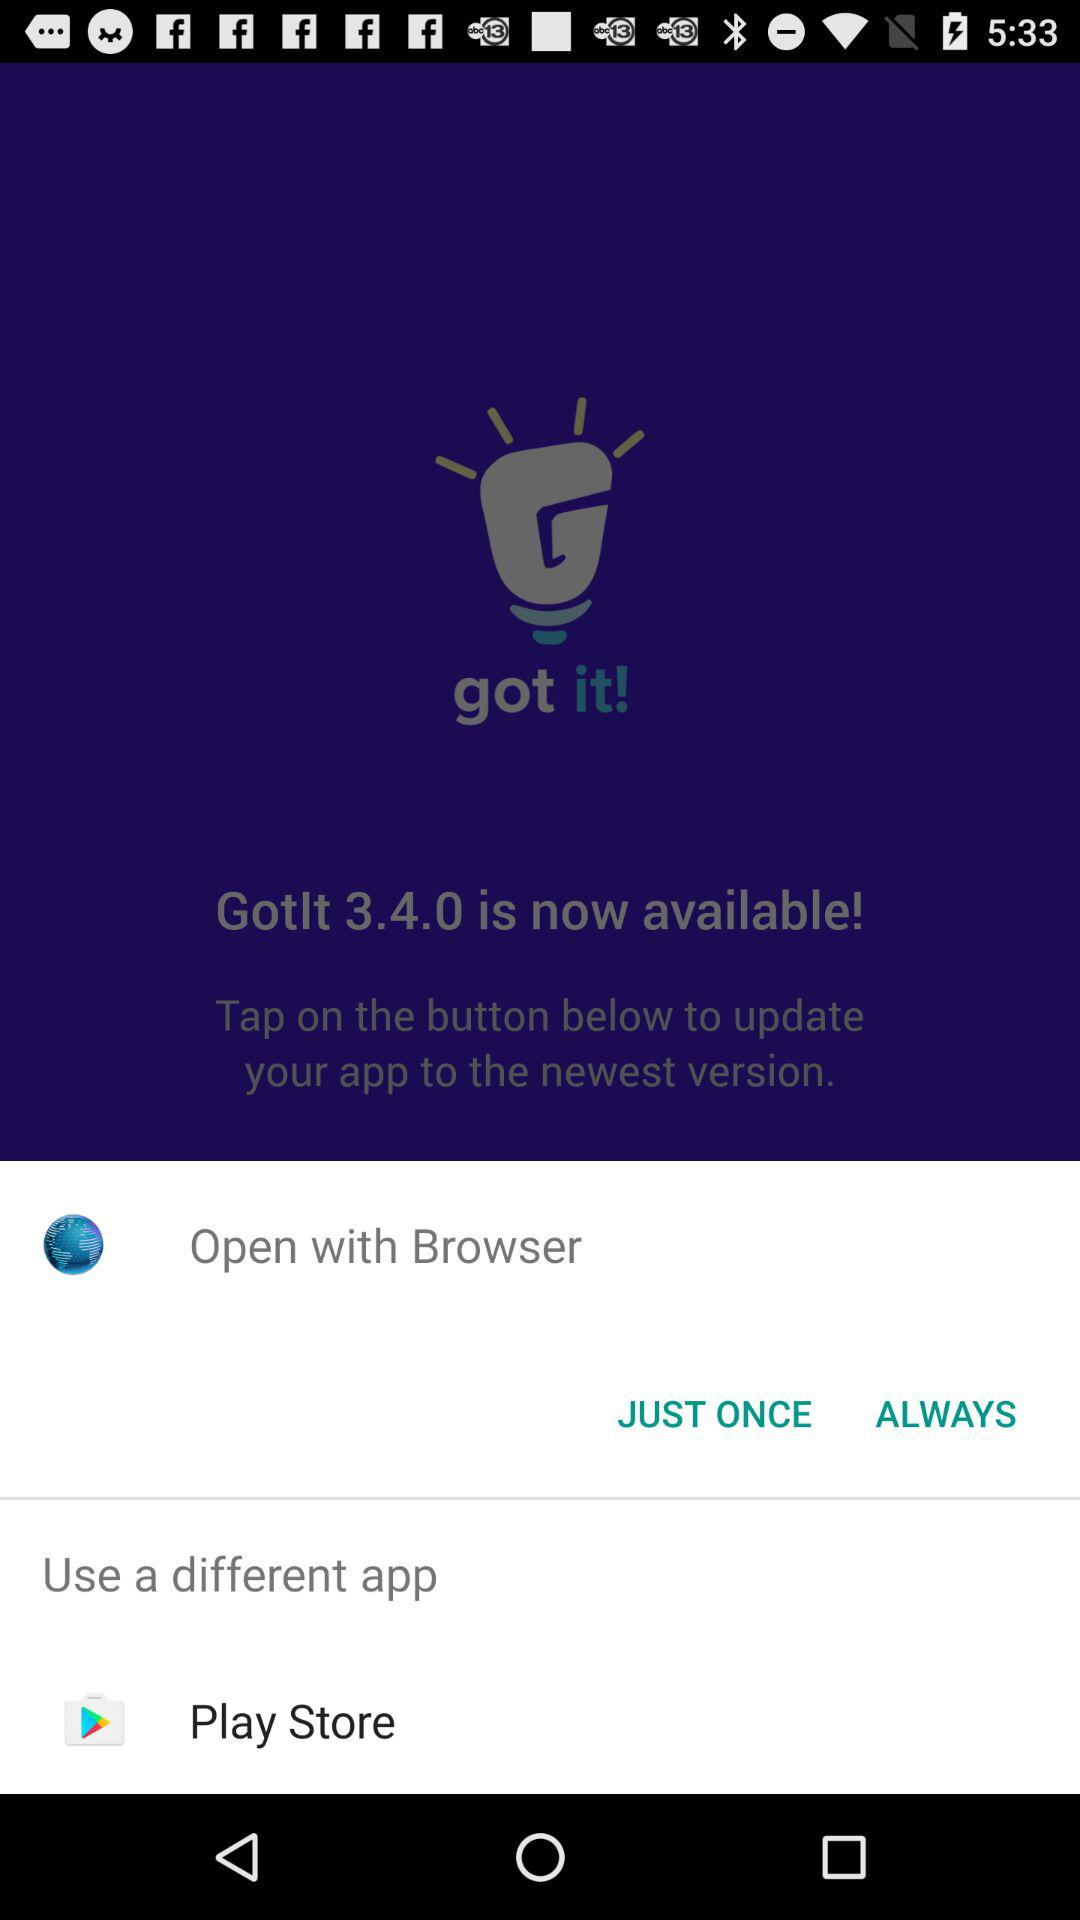What is the name of the application? The names of the applications are "Gotlt", "Browser", and "Play Store". 